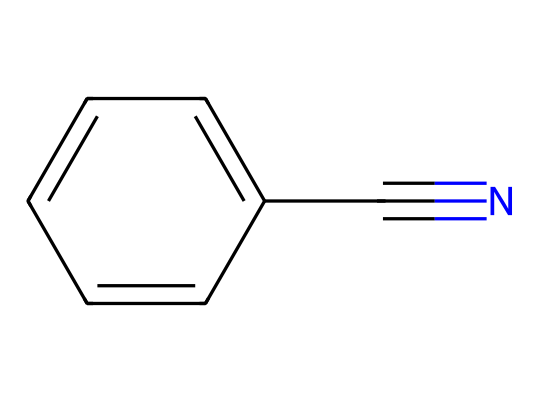What is the common name of this chemical? The chemical shown has the SMILES notation c1ccccc1C#N, which corresponds to benzonitrile. The presence of the nitrile (C#N) group attached to the benzene ring indicates it's specifically this compound.
Answer: benzonitrile How many carbon atoms are present in benzonitrile? Analyzing the structure reveals that it contains seven carbon atoms: six from the benzene ring and one from the nitrile group (C#N).
Answer: 7 What type of functional group is present in this chemical? The structure includes a nitrile group (C#N), which is characterized by a carbon triple-bonded to a nitrogen atom. This defines it as a nitrile compound.
Answer: nitrile Does benzonitrile have aromatic properties? Yes, benzonitrile contains a benzene ring, which is known for its aromatic stability due to resonance. The presence of this ring confirms the aromatic nature of the compound.
Answer: yes What is the hybridization of the carbon in the nitrile group? In the nitrile group (C#N), the carbon atom is bonded to the nitrogen atom by a triple bond, indicating its linear geometry and sp hybridization. This is typical for carbon atoms in nitriles.
Answer: sp Can benzonitrile be used in the synthesis of other compounds? Benzonitrile, due to its nitrile and aromatic characteristics, can be used as a precursor for a variety of reactions, including aromatic substitutions and the synthesis of amines or carboxylic acids.
Answer: yes 